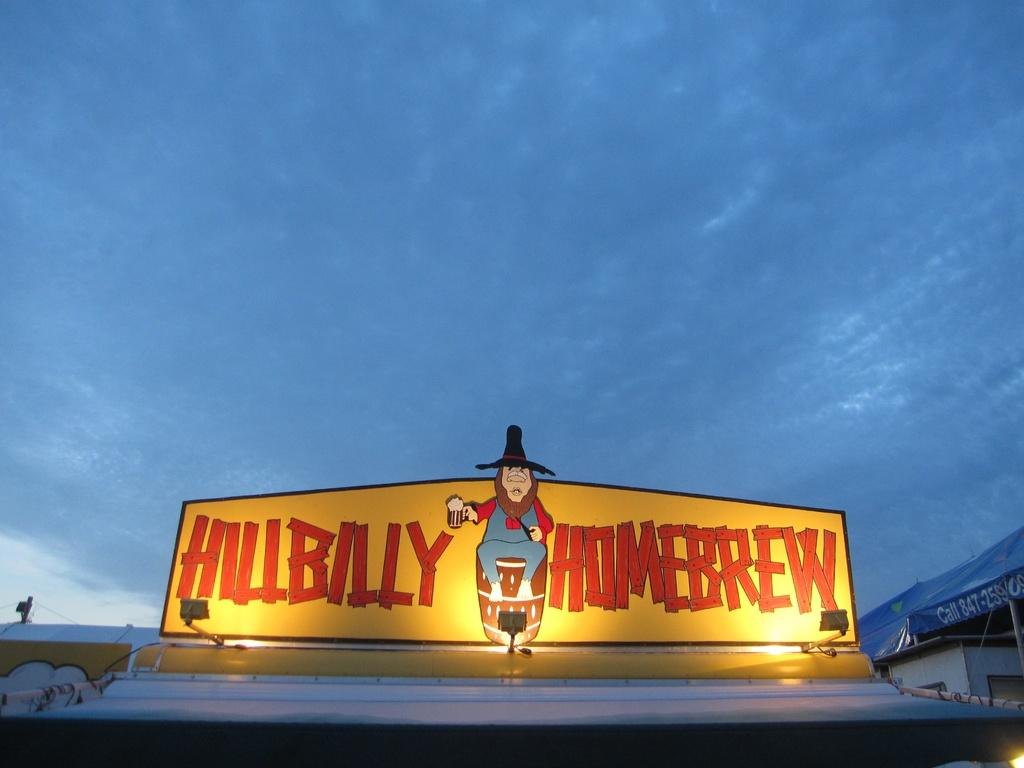What type of structures can be seen in the image? There are buildings in the image. What else is present in the image besides the buildings? There is a banner in the image. What can be seen in the sky in the image? The sky is visible in the image, and clouds are present. Can you see the farmer's tail in the image? There is no farmer or any tails present in the image. 